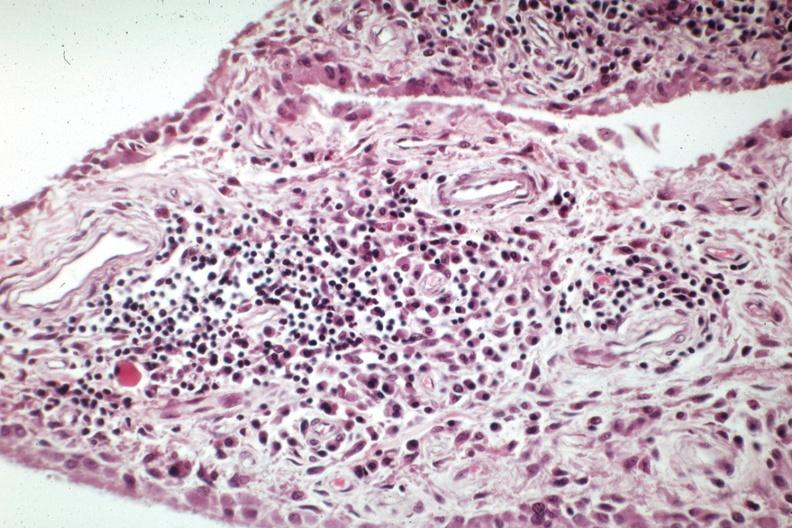what does this image show?
Answer the question using a single word or phrase. Chronic inflammatory cells in synovial villus excellent russell body case 31 